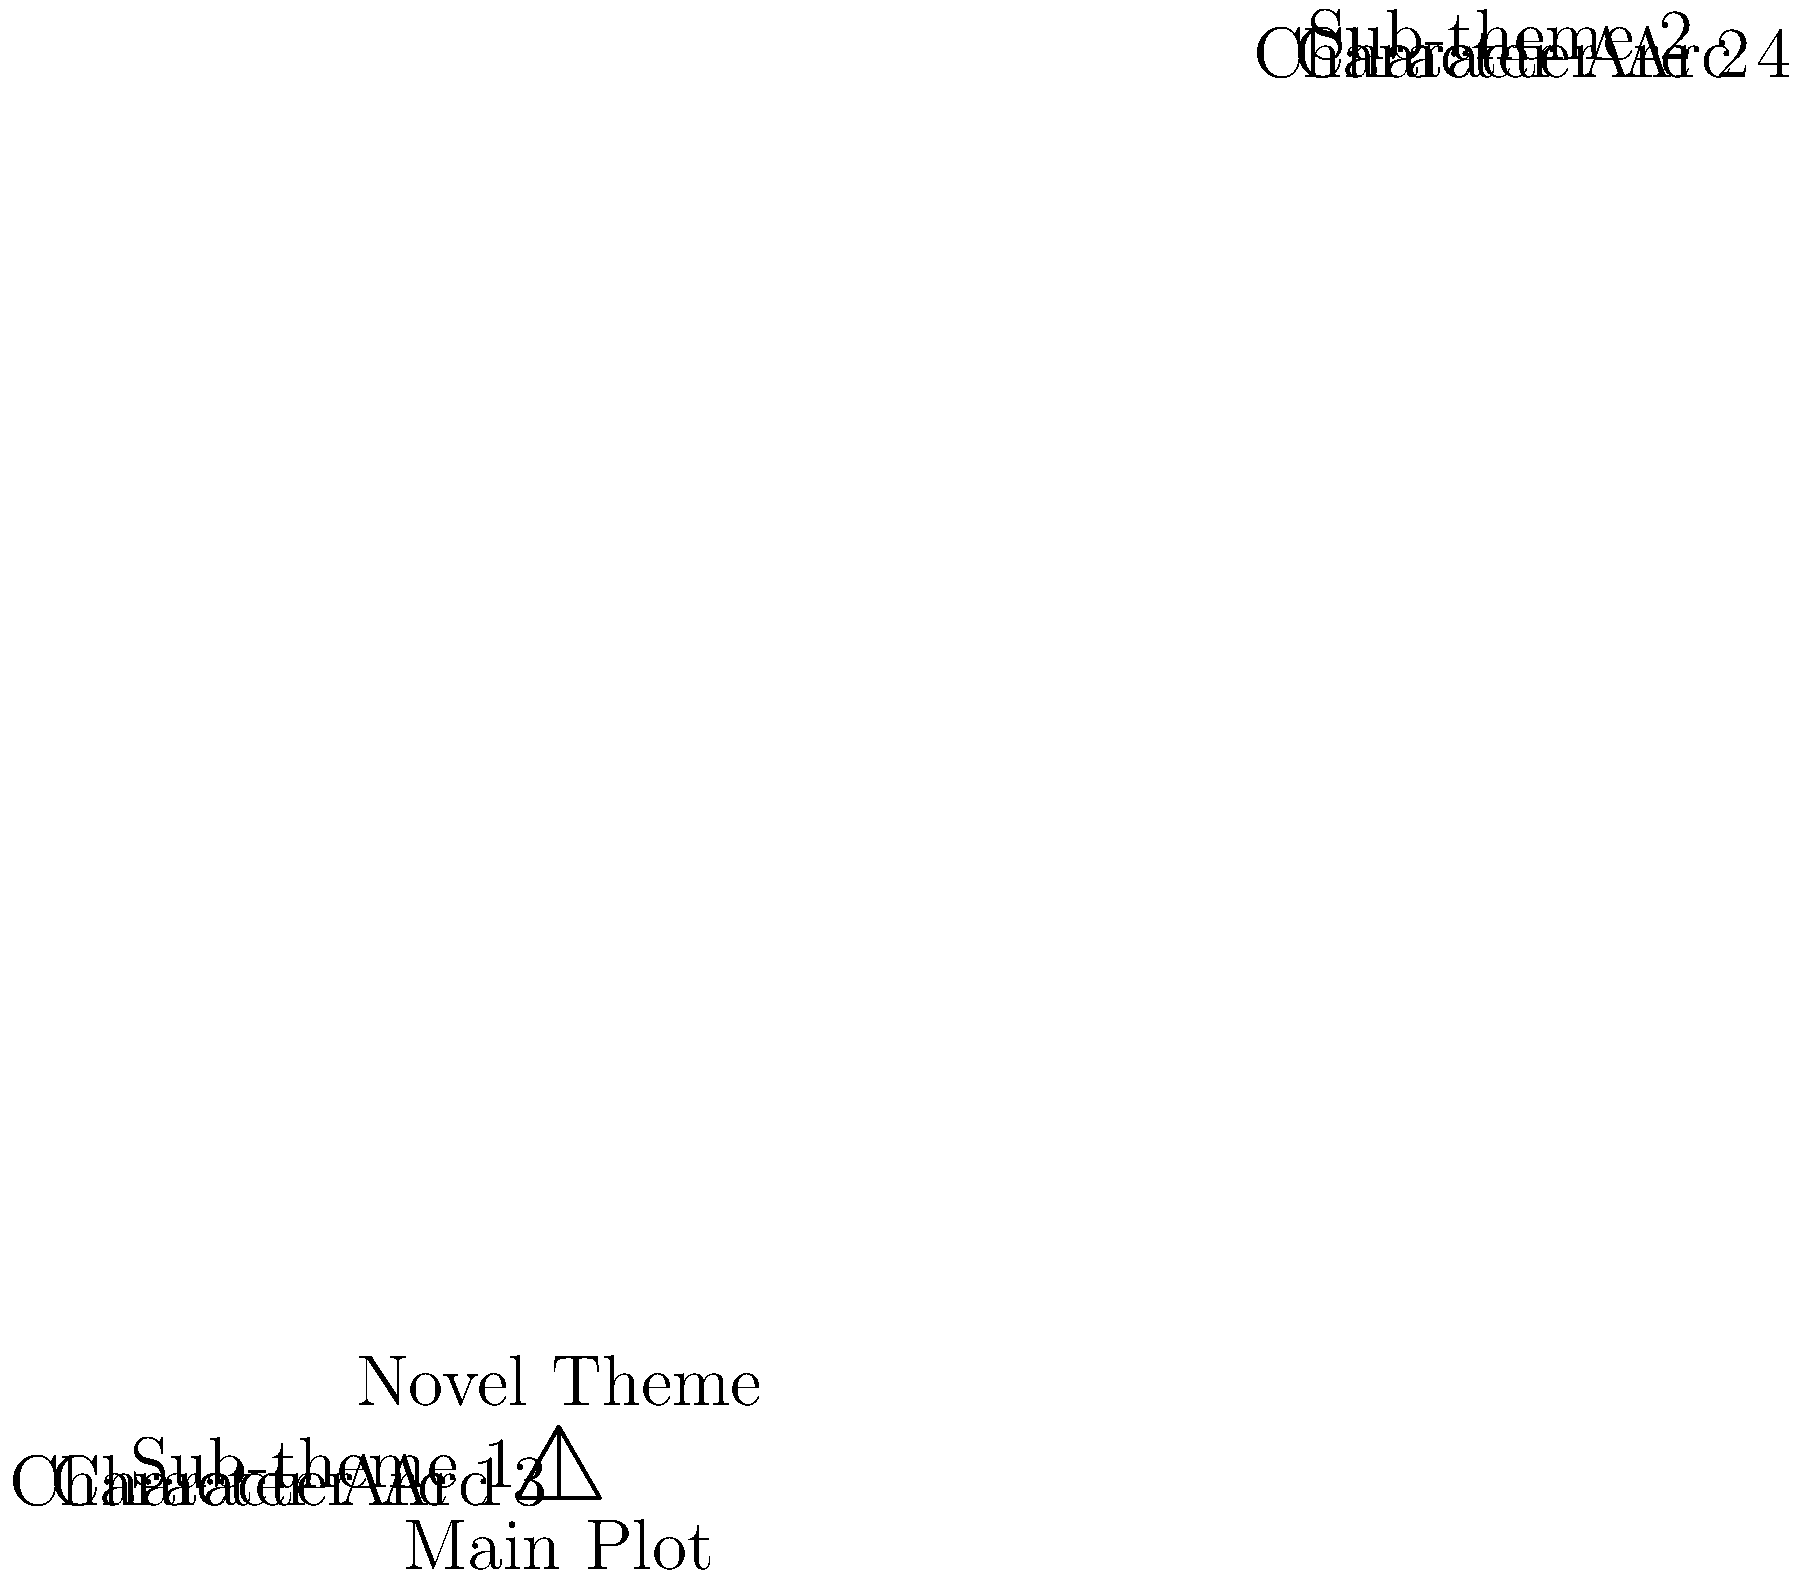Analyze the hierarchical tree diagram representing the thematic structure of a novel. How many levels of depth are present in this thematic structure, and what does each level represent in terms of literary analysis? To answer this question, let's analyze the diagram step-by-step:

1. The topmost point of the triangle represents the overall "Novel Theme". This is the first and highest level of the structure.

2. The second level, directly below the Novel Theme, shows three elements:
   a) "Main Plot" in the center
   b) "Sub-theme 1" on the left
   c) "Sub-theme 2" on the right
   This level represents the primary components that make up the novel's thematic structure.

3. The third and lowest level of the diagram shows four "Character Arc" elements:
   a) Character Arc 1
   b) Character Arc 2
   c) Character Arc 3
   d) Character Arc 4
   These represent individual character developments that contribute to the overall theme and subthemes.

In terms of literary analysis:
- Level 1 (Novel Theme): Represents the overarching message or central idea of the entire work.
- Level 2 (Main Plot and Sub-themes): Shows how the central theme is explored through the primary storyline and supporting thematic elements.
- Level 3 (Character Arcs): Illustrates how individual character developments contribute to and reinforce the main plot and sub-themes, ultimately supporting the novel's central theme.

Therefore, the diagram presents three levels of depth in the thematic structure, each representing a different aspect of literary analysis from broad to specific.
Answer: 3 levels: Theme, Plot/Sub-themes, Character Arcs 